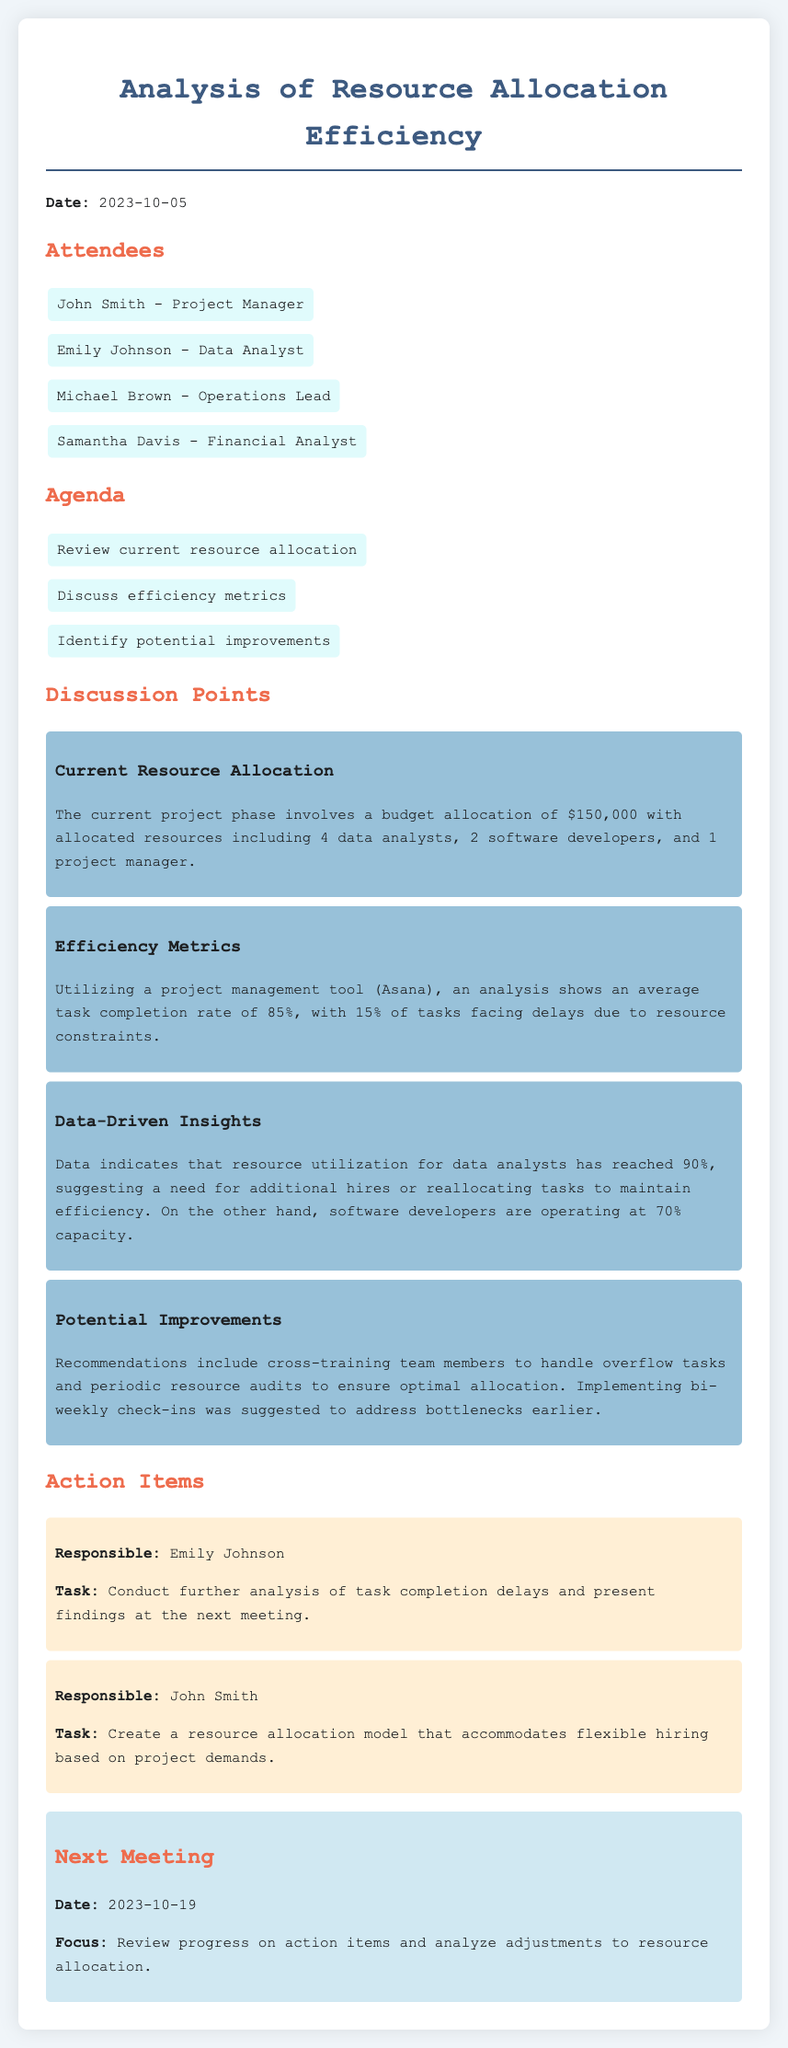What is the date of the meeting? The date of the meeting is mentioned at the beginning of the document.
Answer: 2023-10-05 Who is responsible for conducting further analysis of task completion delays? The action item in the document specifies who is responsible for the task.
Answer: Emily Johnson What is the budget allocation for the current project phase? The document states the budget allocation under the discussion point on current resource allocation.
Answer: $150,000 How many data analysts are allocated in the current project phase? This information is derived from the current resource allocation section of the document.
Answer: 4 What is the average task completion rate reported? The efficiency metrics section provides specific data on task completion rates.
Answer: 85% What is the recommended frequency for check-ins to address bottlenecks? The discussion on potential improvements outlines suggestions for team communication.
Answer: Bi-weekly What is the main focus of the next meeting? The next meeting section summarizes the agenda for the upcoming meeting.
Answer: Review progress on action items and analyze adjustments to resource allocation 